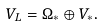Convert formula to latex. <formula><loc_0><loc_0><loc_500><loc_500>V _ { L } = \Omega _ { * } \oplus V _ { * } .</formula> 